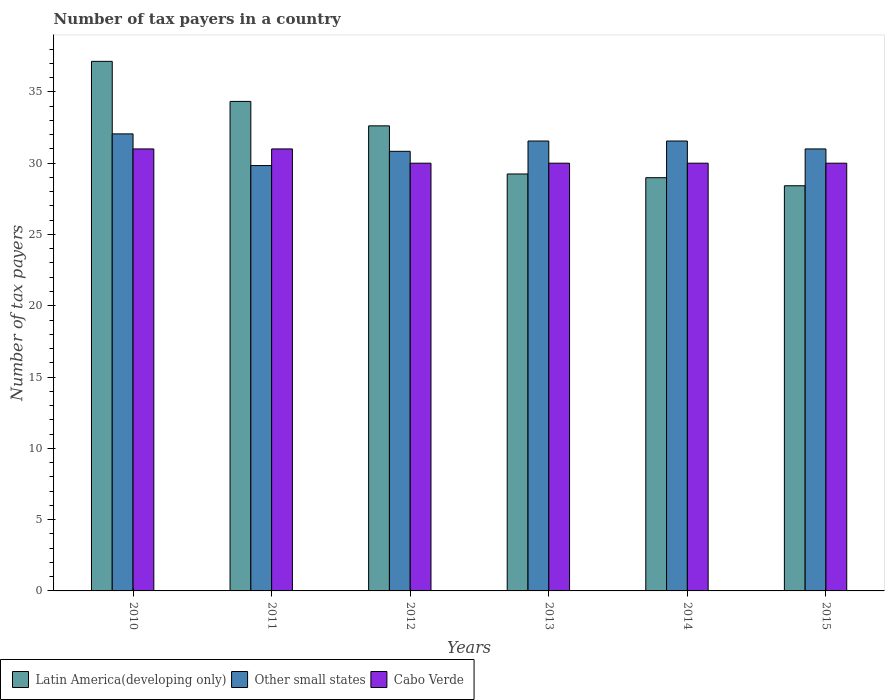How many groups of bars are there?
Offer a very short reply. 6. Are the number of bars on each tick of the X-axis equal?
Offer a terse response. Yes. What is the number of tax payers in in Latin America(developing only) in 2011?
Give a very brief answer. 34.33. Across all years, what is the maximum number of tax payers in in Other small states?
Provide a short and direct response. 32.06. Across all years, what is the minimum number of tax payers in in Cabo Verde?
Provide a succinct answer. 30. In which year was the number of tax payers in in Latin America(developing only) maximum?
Provide a short and direct response. 2010. What is the total number of tax payers in in Cabo Verde in the graph?
Offer a terse response. 182. What is the difference between the number of tax payers in in Other small states in 2013 and that in 2014?
Give a very brief answer. 0. What is the difference between the number of tax payers in in Other small states in 2011 and the number of tax payers in in Latin America(developing only) in 2014?
Make the answer very short. 0.85. What is the average number of tax payers in in Latin America(developing only) per year?
Ensure brevity in your answer.  31.79. In the year 2010, what is the difference between the number of tax payers in in Latin America(developing only) and number of tax payers in in Other small states?
Keep it short and to the point. 5.09. What is the ratio of the number of tax payers in in Latin America(developing only) in 2011 to that in 2014?
Offer a very short reply. 1.18. Is the number of tax payers in in Cabo Verde in 2012 less than that in 2015?
Offer a very short reply. No. What is the difference between the highest and the second highest number of tax payers in in Other small states?
Offer a terse response. 0.5. What is the difference between the highest and the lowest number of tax payers in in Latin America(developing only)?
Give a very brief answer. 8.73. What does the 3rd bar from the left in 2015 represents?
Offer a very short reply. Cabo Verde. What does the 3rd bar from the right in 2013 represents?
Give a very brief answer. Latin America(developing only). How many bars are there?
Make the answer very short. 18. What is the difference between two consecutive major ticks on the Y-axis?
Your answer should be compact. 5. Does the graph contain any zero values?
Give a very brief answer. No. Does the graph contain grids?
Keep it short and to the point. No. Where does the legend appear in the graph?
Offer a terse response. Bottom left. How many legend labels are there?
Give a very brief answer. 3. What is the title of the graph?
Your answer should be compact. Number of tax payers in a country. Does "Japan" appear as one of the legend labels in the graph?
Your answer should be compact. No. What is the label or title of the Y-axis?
Your response must be concise. Number of tax payers. What is the Number of tax payers of Latin America(developing only) in 2010?
Ensure brevity in your answer.  37.14. What is the Number of tax payers of Other small states in 2010?
Provide a short and direct response. 32.06. What is the Number of tax payers in Cabo Verde in 2010?
Offer a terse response. 31. What is the Number of tax payers of Latin America(developing only) in 2011?
Ensure brevity in your answer.  34.33. What is the Number of tax payers in Other small states in 2011?
Offer a terse response. 29.83. What is the Number of tax payers of Cabo Verde in 2011?
Provide a succinct answer. 31. What is the Number of tax payers in Latin America(developing only) in 2012?
Keep it short and to the point. 32.62. What is the Number of tax payers of Other small states in 2012?
Provide a short and direct response. 30.83. What is the Number of tax payers of Latin America(developing only) in 2013?
Offer a very short reply. 29.24. What is the Number of tax payers of Other small states in 2013?
Provide a succinct answer. 31.56. What is the Number of tax payers in Cabo Verde in 2013?
Offer a very short reply. 30. What is the Number of tax payers of Latin America(developing only) in 2014?
Offer a very short reply. 28.98. What is the Number of tax payers of Other small states in 2014?
Provide a short and direct response. 31.56. What is the Number of tax payers of Latin America(developing only) in 2015?
Your answer should be compact. 28.42. What is the Number of tax payers of Other small states in 2015?
Keep it short and to the point. 31. Across all years, what is the maximum Number of tax payers of Latin America(developing only)?
Make the answer very short. 37.14. Across all years, what is the maximum Number of tax payers in Other small states?
Provide a succinct answer. 32.06. Across all years, what is the maximum Number of tax payers of Cabo Verde?
Your answer should be compact. 31. Across all years, what is the minimum Number of tax payers of Latin America(developing only)?
Make the answer very short. 28.42. Across all years, what is the minimum Number of tax payers of Other small states?
Provide a succinct answer. 29.83. What is the total Number of tax payers of Latin America(developing only) in the graph?
Keep it short and to the point. 190.74. What is the total Number of tax payers in Other small states in the graph?
Provide a succinct answer. 186.83. What is the total Number of tax payers in Cabo Verde in the graph?
Offer a terse response. 182. What is the difference between the Number of tax payers of Latin America(developing only) in 2010 and that in 2011?
Keep it short and to the point. 2.81. What is the difference between the Number of tax payers in Other small states in 2010 and that in 2011?
Provide a succinct answer. 2.22. What is the difference between the Number of tax payers of Cabo Verde in 2010 and that in 2011?
Offer a very short reply. 0. What is the difference between the Number of tax payers of Latin America(developing only) in 2010 and that in 2012?
Your answer should be very brief. 4.52. What is the difference between the Number of tax payers in Other small states in 2010 and that in 2012?
Keep it short and to the point. 1.22. What is the difference between the Number of tax payers in Cabo Verde in 2010 and that in 2012?
Give a very brief answer. 1. What is the difference between the Number of tax payers of Latin America(developing only) in 2010 and that in 2013?
Offer a terse response. 7.9. What is the difference between the Number of tax payers in Other small states in 2010 and that in 2013?
Your answer should be compact. 0.5. What is the difference between the Number of tax payers in Latin America(developing only) in 2010 and that in 2014?
Offer a very short reply. 8.16. What is the difference between the Number of tax payers of Other small states in 2010 and that in 2014?
Ensure brevity in your answer.  0.5. What is the difference between the Number of tax payers in Latin America(developing only) in 2010 and that in 2015?
Make the answer very short. 8.73. What is the difference between the Number of tax payers of Other small states in 2010 and that in 2015?
Your answer should be very brief. 1.06. What is the difference between the Number of tax payers in Cabo Verde in 2010 and that in 2015?
Provide a short and direct response. 1. What is the difference between the Number of tax payers in Latin America(developing only) in 2011 and that in 2012?
Your response must be concise. 1.71. What is the difference between the Number of tax payers in Other small states in 2011 and that in 2012?
Make the answer very short. -1. What is the difference between the Number of tax payers of Cabo Verde in 2011 and that in 2012?
Provide a short and direct response. 1. What is the difference between the Number of tax payers in Latin America(developing only) in 2011 and that in 2013?
Provide a succinct answer. 5.09. What is the difference between the Number of tax payers in Other small states in 2011 and that in 2013?
Provide a short and direct response. -1.72. What is the difference between the Number of tax payers in Cabo Verde in 2011 and that in 2013?
Make the answer very short. 1. What is the difference between the Number of tax payers in Latin America(developing only) in 2011 and that in 2014?
Your response must be concise. 5.35. What is the difference between the Number of tax payers of Other small states in 2011 and that in 2014?
Your response must be concise. -1.72. What is the difference between the Number of tax payers of Latin America(developing only) in 2011 and that in 2015?
Your response must be concise. 5.92. What is the difference between the Number of tax payers of Other small states in 2011 and that in 2015?
Keep it short and to the point. -1.17. What is the difference between the Number of tax payers in Latin America(developing only) in 2012 and that in 2013?
Provide a succinct answer. 3.38. What is the difference between the Number of tax payers of Other small states in 2012 and that in 2013?
Your answer should be compact. -0.72. What is the difference between the Number of tax payers of Latin America(developing only) in 2012 and that in 2014?
Provide a short and direct response. 3.64. What is the difference between the Number of tax payers of Other small states in 2012 and that in 2014?
Make the answer very short. -0.72. What is the difference between the Number of tax payers of Cabo Verde in 2012 and that in 2014?
Ensure brevity in your answer.  0. What is the difference between the Number of tax payers in Latin America(developing only) in 2012 and that in 2015?
Keep it short and to the point. 4.2. What is the difference between the Number of tax payers in Latin America(developing only) in 2013 and that in 2014?
Offer a very short reply. 0.26. What is the difference between the Number of tax payers in Latin America(developing only) in 2013 and that in 2015?
Offer a very short reply. 0.83. What is the difference between the Number of tax payers of Other small states in 2013 and that in 2015?
Give a very brief answer. 0.56. What is the difference between the Number of tax payers in Cabo Verde in 2013 and that in 2015?
Offer a very short reply. 0. What is the difference between the Number of tax payers of Latin America(developing only) in 2014 and that in 2015?
Your answer should be very brief. 0.57. What is the difference between the Number of tax payers in Other small states in 2014 and that in 2015?
Your response must be concise. 0.56. What is the difference between the Number of tax payers of Cabo Verde in 2014 and that in 2015?
Offer a terse response. 0. What is the difference between the Number of tax payers of Latin America(developing only) in 2010 and the Number of tax payers of Other small states in 2011?
Provide a succinct answer. 7.31. What is the difference between the Number of tax payers of Latin America(developing only) in 2010 and the Number of tax payers of Cabo Verde in 2011?
Give a very brief answer. 6.14. What is the difference between the Number of tax payers of Other small states in 2010 and the Number of tax payers of Cabo Verde in 2011?
Offer a terse response. 1.06. What is the difference between the Number of tax payers in Latin America(developing only) in 2010 and the Number of tax payers in Other small states in 2012?
Provide a short and direct response. 6.31. What is the difference between the Number of tax payers of Latin America(developing only) in 2010 and the Number of tax payers of Cabo Verde in 2012?
Your response must be concise. 7.14. What is the difference between the Number of tax payers of Other small states in 2010 and the Number of tax payers of Cabo Verde in 2012?
Your answer should be compact. 2.06. What is the difference between the Number of tax payers in Latin America(developing only) in 2010 and the Number of tax payers in Other small states in 2013?
Your answer should be compact. 5.59. What is the difference between the Number of tax payers in Latin America(developing only) in 2010 and the Number of tax payers in Cabo Verde in 2013?
Make the answer very short. 7.14. What is the difference between the Number of tax payers in Other small states in 2010 and the Number of tax payers in Cabo Verde in 2013?
Provide a short and direct response. 2.06. What is the difference between the Number of tax payers in Latin America(developing only) in 2010 and the Number of tax payers in Other small states in 2014?
Keep it short and to the point. 5.59. What is the difference between the Number of tax payers of Latin America(developing only) in 2010 and the Number of tax payers of Cabo Verde in 2014?
Your answer should be compact. 7.14. What is the difference between the Number of tax payers of Other small states in 2010 and the Number of tax payers of Cabo Verde in 2014?
Provide a short and direct response. 2.06. What is the difference between the Number of tax payers in Latin America(developing only) in 2010 and the Number of tax payers in Other small states in 2015?
Keep it short and to the point. 6.14. What is the difference between the Number of tax payers of Latin America(developing only) in 2010 and the Number of tax payers of Cabo Verde in 2015?
Ensure brevity in your answer.  7.14. What is the difference between the Number of tax payers in Other small states in 2010 and the Number of tax payers in Cabo Verde in 2015?
Keep it short and to the point. 2.06. What is the difference between the Number of tax payers in Latin America(developing only) in 2011 and the Number of tax payers in Other small states in 2012?
Your response must be concise. 3.5. What is the difference between the Number of tax payers in Latin America(developing only) in 2011 and the Number of tax payers in Cabo Verde in 2012?
Your answer should be compact. 4.33. What is the difference between the Number of tax payers in Other small states in 2011 and the Number of tax payers in Cabo Verde in 2012?
Your answer should be very brief. -0.17. What is the difference between the Number of tax payers in Latin America(developing only) in 2011 and the Number of tax payers in Other small states in 2013?
Offer a terse response. 2.78. What is the difference between the Number of tax payers in Latin America(developing only) in 2011 and the Number of tax payers in Cabo Verde in 2013?
Give a very brief answer. 4.33. What is the difference between the Number of tax payers of Other small states in 2011 and the Number of tax payers of Cabo Verde in 2013?
Provide a short and direct response. -0.17. What is the difference between the Number of tax payers of Latin America(developing only) in 2011 and the Number of tax payers of Other small states in 2014?
Keep it short and to the point. 2.78. What is the difference between the Number of tax payers in Latin America(developing only) in 2011 and the Number of tax payers in Cabo Verde in 2014?
Keep it short and to the point. 4.33. What is the difference between the Number of tax payers of Other small states in 2011 and the Number of tax payers of Cabo Verde in 2014?
Your answer should be very brief. -0.17. What is the difference between the Number of tax payers of Latin America(developing only) in 2011 and the Number of tax payers of Cabo Verde in 2015?
Ensure brevity in your answer.  4.33. What is the difference between the Number of tax payers in Other small states in 2011 and the Number of tax payers in Cabo Verde in 2015?
Ensure brevity in your answer.  -0.17. What is the difference between the Number of tax payers in Latin America(developing only) in 2012 and the Number of tax payers in Other small states in 2013?
Your answer should be compact. 1.06. What is the difference between the Number of tax payers in Latin America(developing only) in 2012 and the Number of tax payers in Cabo Verde in 2013?
Ensure brevity in your answer.  2.62. What is the difference between the Number of tax payers in Latin America(developing only) in 2012 and the Number of tax payers in Other small states in 2014?
Your answer should be compact. 1.06. What is the difference between the Number of tax payers in Latin America(developing only) in 2012 and the Number of tax payers in Cabo Verde in 2014?
Make the answer very short. 2.62. What is the difference between the Number of tax payers in Latin America(developing only) in 2012 and the Number of tax payers in Other small states in 2015?
Give a very brief answer. 1.62. What is the difference between the Number of tax payers in Latin America(developing only) in 2012 and the Number of tax payers in Cabo Verde in 2015?
Your answer should be very brief. 2.62. What is the difference between the Number of tax payers in Latin America(developing only) in 2013 and the Number of tax payers in Other small states in 2014?
Offer a terse response. -2.31. What is the difference between the Number of tax payers in Latin America(developing only) in 2013 and the Number of tax payers in Cabo Verde in 2014?
Provide a succinct answer. -0.76. What is the difference between the Number of tax payers of Other small states in 2013 and the Number of tax payers of Cabo Verde in 2014?
Offer a very short reply. 1.56. What is the difference between the Number of tax payers in Latin America(developing only) in 2013 and the Number of tax payers in Other small states in 2015?
Offer a terse response. -1.76. What is the difference between the Number of tax payers of Latin America(developing only) in 2013 and the Number of tax payers of Cabo Verde in 2015?
Your response must be concise. -0.76. What is the difference between the Number of tax payers in Other small states in 2013 and the Number of tax payers in Cabo Verde in 2015?
Offer a very short reply. 1.56. What is the difference between the Number of tax payers of Latin America(developing only) in 2014 and the Number of tax payers of Other small states in 2015?
Your answer should be compact. -2.02. What is the difference between the Number of tax payers of Latin America(developing only) in 2014 and the Number of tax payers of Cabo Verde in 2015?
Your response must be concise. -1.02. What is the difference between the Number of tax payers of Other small states in 2014 and the Number of tax payers of Cabo Verde in 2015?
Give a very brief answer. 1.56. What is the average Number of tax payers of Latin America(developing only) per year?
Provide a succinct answer. 31.79. What is the average Number of tax payers of Other small states per year?
Ensure brevity in your answer.  31.14. What is the average Number of tax payers of Cabo Verde per year?
Ensure brevity in your answer.  30.33. In the year 2010, what is the difference between the Number of tax payers of Latin America(developing only) and Number of tax payers of Other small states?
Your response must be concise. 5.09. In the year 2010, what is the difference between the Number of tax payers of Latin America(developing only) and Number of tax payers of Cabo Verde?
Provide a succinct answer. 6.14. In the year 2010, what is the difference between the Number of tax payers of Other small states and Number of tax payers of Cabo Verde?
Ensure brevity in your answer.  1.06. In the year 2011, what is the difference between the Number of tax payers in Latin America(developing only) and Number of tax payers in Cabo Verde?
Ensure brevity in your answer.  3.33. In the year 2011, what is the difference between the Number of tax payers in Other small states and Number of tax payers in Cabo Verde?
Ensure brevity in your answer.  -1.17. In the year 2012, what is the difference between the Number of tax payers of Latin America(developing only) and Number of tax payers of Other small states?
Keep it short and to the point. 1.79. In the year 2012, what is the difference between the Number of tax payers of Latin America(developing only) and Number of tax payers of Cabo Verde?
Give a very brief answer. 2.62. In the year 2012, what is the difference between the Number of tax payers of Other small states and Number of tax payers of Cabo Verde?
Ensure brevity in your answer.  0.83. In the year 2013, what is the difference between the Number of tax payers of Latin America(developing only) and Number of tax payers of Other small states?
Offer a very short reply. -2.31. In the year 2013, what is the difference between the Number of tax payers of Latin America(developing only) and Number of tax payers of Cabo Verde?
Provide a short and direct response. -0.76. In the year 2013, what is the difference between the Number of tax payers in Other small states and Number of tax payers in Cabo Verde?
Your response must be concise. 1.56. In the year 2014, what is the difference between the Number of tax payers of Latin America(developing only) and Number of tax payers of Other small states?
Offer a terse response. -2.57. In the year 2014, what is the difference between the Number of tax payers in Latin America(developing only) and Number of tax payers in Cabo Verde?
Make the answer very short. -1.02. In the year 2014, what is the difference between the Number of tax payers in Other small states and Number of tax payers in Cabo Verde?
Provide a succinct answer. 1.56. In the year 2015, what is the difference between the Number of tax payers in Latin America(developing only) and Number of tax payers in Other small states?
Your answer should be very brief. -2.58. In the year 2015, what is the difference between the Number of tax payers of Latin America(developing only) and Number of tax payers of Cabo Verde?
Your answer should be compact. -1.58. In the year 2015, what is the difference between the Number of tax payers of Other small states and Number of tax payers of Cabo Verde?
Your answer should be very brief. 1. What is the ratio of the Number of tax payers in Latin America(developing only) in 2010 to that in 2011?
Offer a very short reply. 1.08. What is the ratio of the Number of tax payers of Other small states in 2010 to that in 2011?
Offer a very short reply. 1.07. What is the ratio of the Number of tax payers of Latin America(developing only) in 2010 to that in 2012?
Make the answer very short. 1.14. What is the ratio of the Number of tax payers in Other small states in 2010 to that in 2012?
Give a very brief answer. 1.04. What is the ratio of the Number of tax payers in Cabo Verde in 2010 to that in 2012?
Your response must be concise. 1.03. What is the ratio of the Number of tax payers of Latin America(developing only) in 2010 to that in 2013?
Your answer should be compact. 1.27. What is the ratio of the Number of tax payers of Other small states in 2010 to that in 2013?
Your answer should be very brief. 1.02. What is the ratio of the Number of tax payers in Latin America(developing only) in 2010 to that in 2014?
Your response must be concise. 1.28. What is the ratio of the Number of tax payers in Other small states in 2010 to that in 2014?
Keep it short and to the point. 1.02. What is the ratio of the Number of tax payers in Cabo Verde in 2010 to that in 2014?
Offer a very short reply. 1.03. What is the ratio of the Number of tax payers in Latin America(developing only) in 2010 to that in 2015?
Your answer should be compact. 1.31. What is the ratio of the Number of tax payers of Other small states in 2010 to that in 2015?
Make the answer very short. 1.03. What is the ratio of the Number of tax payers of Cabo Verde in 2010 to that in 2015?
Your response must be concise. 1.03. What is the ratio of the Number of tax payers in Latin America(developing only) in 2011 to that in 2012?
Your response must be concise. 1.05. What is the ratio of the Number of tax payers of Other small states in 2011 to that in 2012?
Keep it short and to the point. 0.97. What is the ratio of the Number of tax payers of Latin America(developing only) in 2011 to that in 2013?
Your answer should be very brief. 1.17. What is the ratio of the Number of tax payers in Other small states in 2011 to that in 2013?
Give a very brief answer. 0.95. What is the ratio of the Number of tax payers in Latin America(developing only) in 2011 to that in 2014?
Give a very brief answer. 1.18. What is the ratio of the Number of tax payers in Other small states in 2011 to that in 2014?
Keep it short and to the point. 0.95. What is the ratio of the Number of tax payers in Cabo Verde in 2011 to that in 2014?
Your answer should be compact. 1.03. What is the ratio of the Number of tax payers of Latin America(developing only) in 2011 to that in 2015?
Provide a succinct answer. 1.21. What is the ratio of the Number of tax payers in Other small states in 2011 to that in 2015?
Make the answer very short. 0.96. What is the ratio of the Number of tax payers of Latin America(developing only) in 2012 to that in 2013?
Your response must be concise. 1.12. What is the ratio of the Number of tax payers in Other small states in 2012 to that in 2013?
Give a very brief answer. 0.98. What is the ratio of the Number of tax payers of Cabo Verde in 2012 to that in 2013?
Provide a short and direct response. 1. What is the ratio of the Number of tax payers of Latin America(developing only) in 2012 to that in 2014?
Your response must be concise. 1.13. What is the ratio of the Number of tax payers of Other small states in 2012 to that in 2014?
Make the answer very short. 0.98. What is the ratio of the Number of tax payers in Cabo Verde in 2012 to that in 2014?
Provide a succinct answer. 1. What is the ratio of the Number of tax payers of Latin America(developing only) in 2012 to that in 2015?
Your response must be concise. 1.15. What is the ratio of the Number of tax payers of Other small states in 2012 to that in 2015?
Provide a short and direct response. 0.99. What is the ratio of the Number of tax payers of Cabo Verde in 2012 to that in 2015?
Keep it short and to the point. 1. What is the ratio of the Number of tax payers in Latin America(developing only) in 2013 to that in 2014?
Provide a short and direct response. 1.01. What is the ratio of the Number of tax payers in Other small states in 2013 to that in 2014?
Keep it short and to the point. 1. What is the ratio of the Number of tax payers of Cabo Verde in 2013 to that in 2014?
Make the answer very short. 1. What is the ratio of the Number of tax payers of Latin America(developing only) in 2013 to that in 2015?
Your answer should be very brief. 1.03. What is the ratio of the Number of tax payers in Other small states in 2013 to that in 2015?
Give a very brief answer. 1.02. What is the ratio of the Number of tax payers in Latin America(developing only) in 2014 to that in 2015?
Your answer should be very brief. 1.02. What is the ratio of the Number of tax payers of Other small states in 2014 to that in 2015?
Your answer should be compact. 1.02. What is the difference between the highest and the second highest Number of tax payers in Latin America(developing only)?
Ensure brevity in your answer.  2.81. What is the difference between the highest and the second highest Number of tax payers in Other small states?
Keep it short and to the point. 0.5. What is the difference between the highest and the second highest Number of tax payers in Cabo Verde?
Your answer should be compact. 0. What is the difference between the highest and the lowest Number of tax payers in Latin America(developing only)?
Provide a succinct answer. 8.73. What is the difference between the highest and the lowest Number of tax payers in Other small states?
Ensure brevity in your answer.  2.22. What is the difference between the highest and the lowest Number of tax payers in Cabo Verde?
Your answer should be compact. 1. 